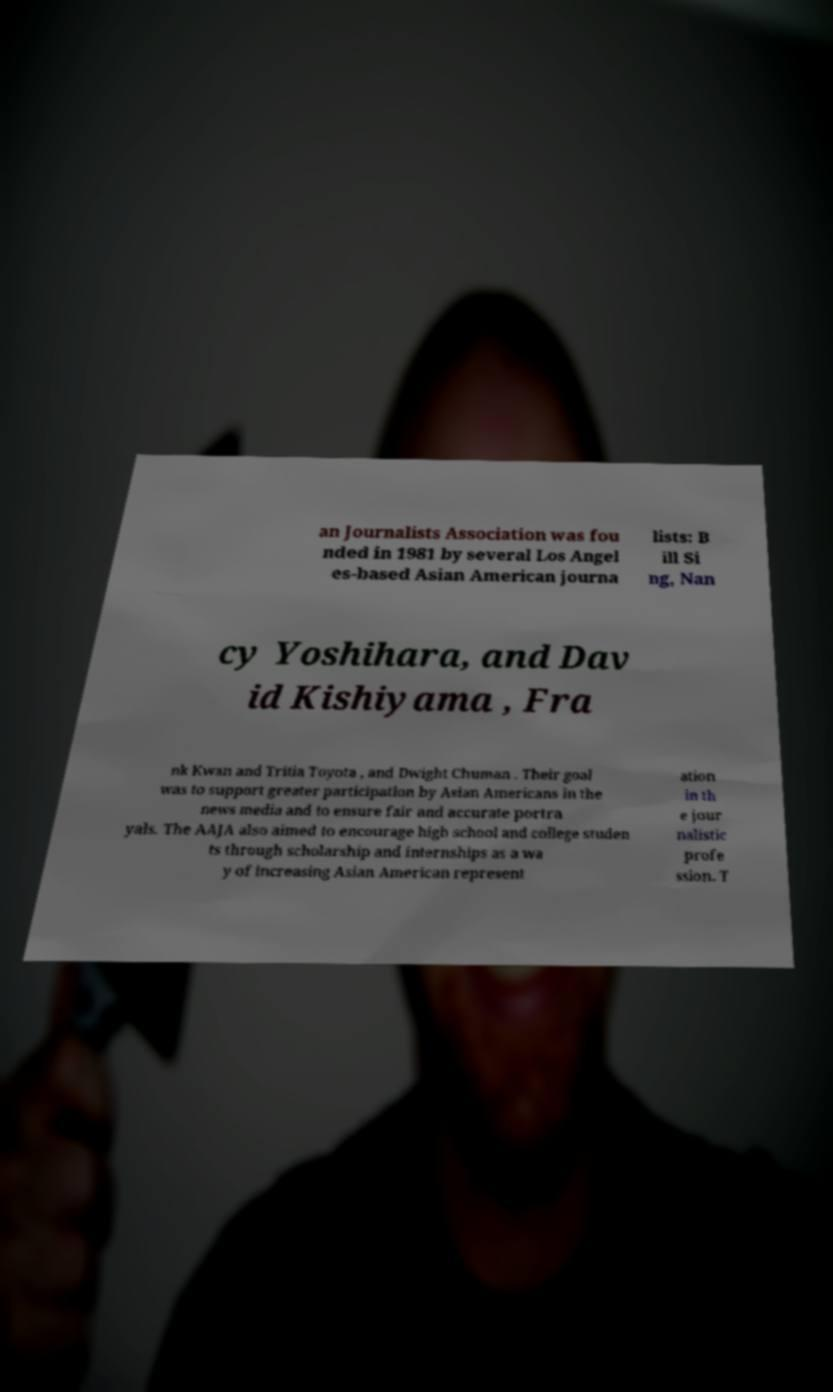Could you assist in decoding the text presented in this image and type it out clearly? an Journalists Association was fou nded in 1981 by several Los Angel es-based Asian American journa lists: B ill Si ng, Nan cy Yoshihara, and Dav id Kishiyama , Fra nk Kwan and Tritia Toyota , and Dwight Chuman . Their goal was to support greater participation by Asian Americans in the news media and to ensure fair and accurate portra yals. The AAJA also aimed to encourage high school and college studen ts through scholarship and internships as a wa y of increasing Asian American represent ation in th e jour nalistic profe ssion. T 